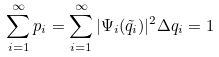<formula> <loc_0><loc_0><loc_500><loc_500>\sum _ { i = 1 } ^ { \infty } p _ { i } = \sum _ { i = 1 } ^ { \infty } | \Psi _ { i } ( \tilde { q } _ { i } ) | ^ { 2 } \Delta q _ { i } = 1</formula> 